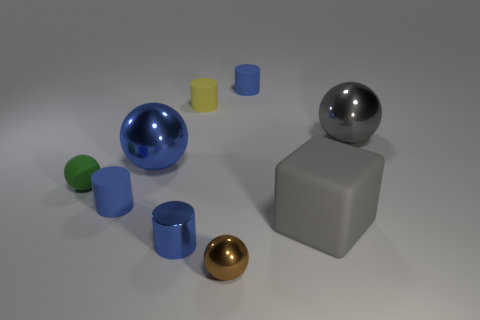Subtract all green blocks. How many blue cylinders are left? 3 Subtract 1 balls. How many balls are left? 3 Subtract all spheres. How many objects are left? 5 Subtract 0 yellow blocks. How many objects are left? 9 Subtract all large gray balls. Subtract all tiny blue matte things. How many objects are left? 6 Add 5 large matte blocks. How many large matte blocks are left? 6 Add 4 tiny red cylinders. How many tiny red cylinders exist? 4 